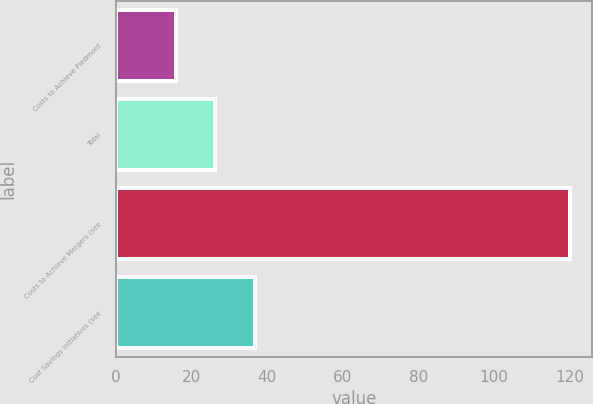<chart> <loc_0><loc_0><loc_500><loc_500><bar_chart><fcel>Costs to Achieve Piedmont<fcel>Total<fcel>Costs to Achieve Mergers (see<fcel>Cost Savings Initiatives (see<nl><fcel>16<fcel>26.4<fcel>120<fcel>36.8<nl></chart> 